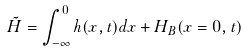Convert formula to latex. <formula><loc_0><loc_0><loc_500><loc_500>\tilde { H } = \int _ { - \infty } ^ { 0 } h ( x , t ) d x + H _ { B } ( x = 0 , t )</formula> 